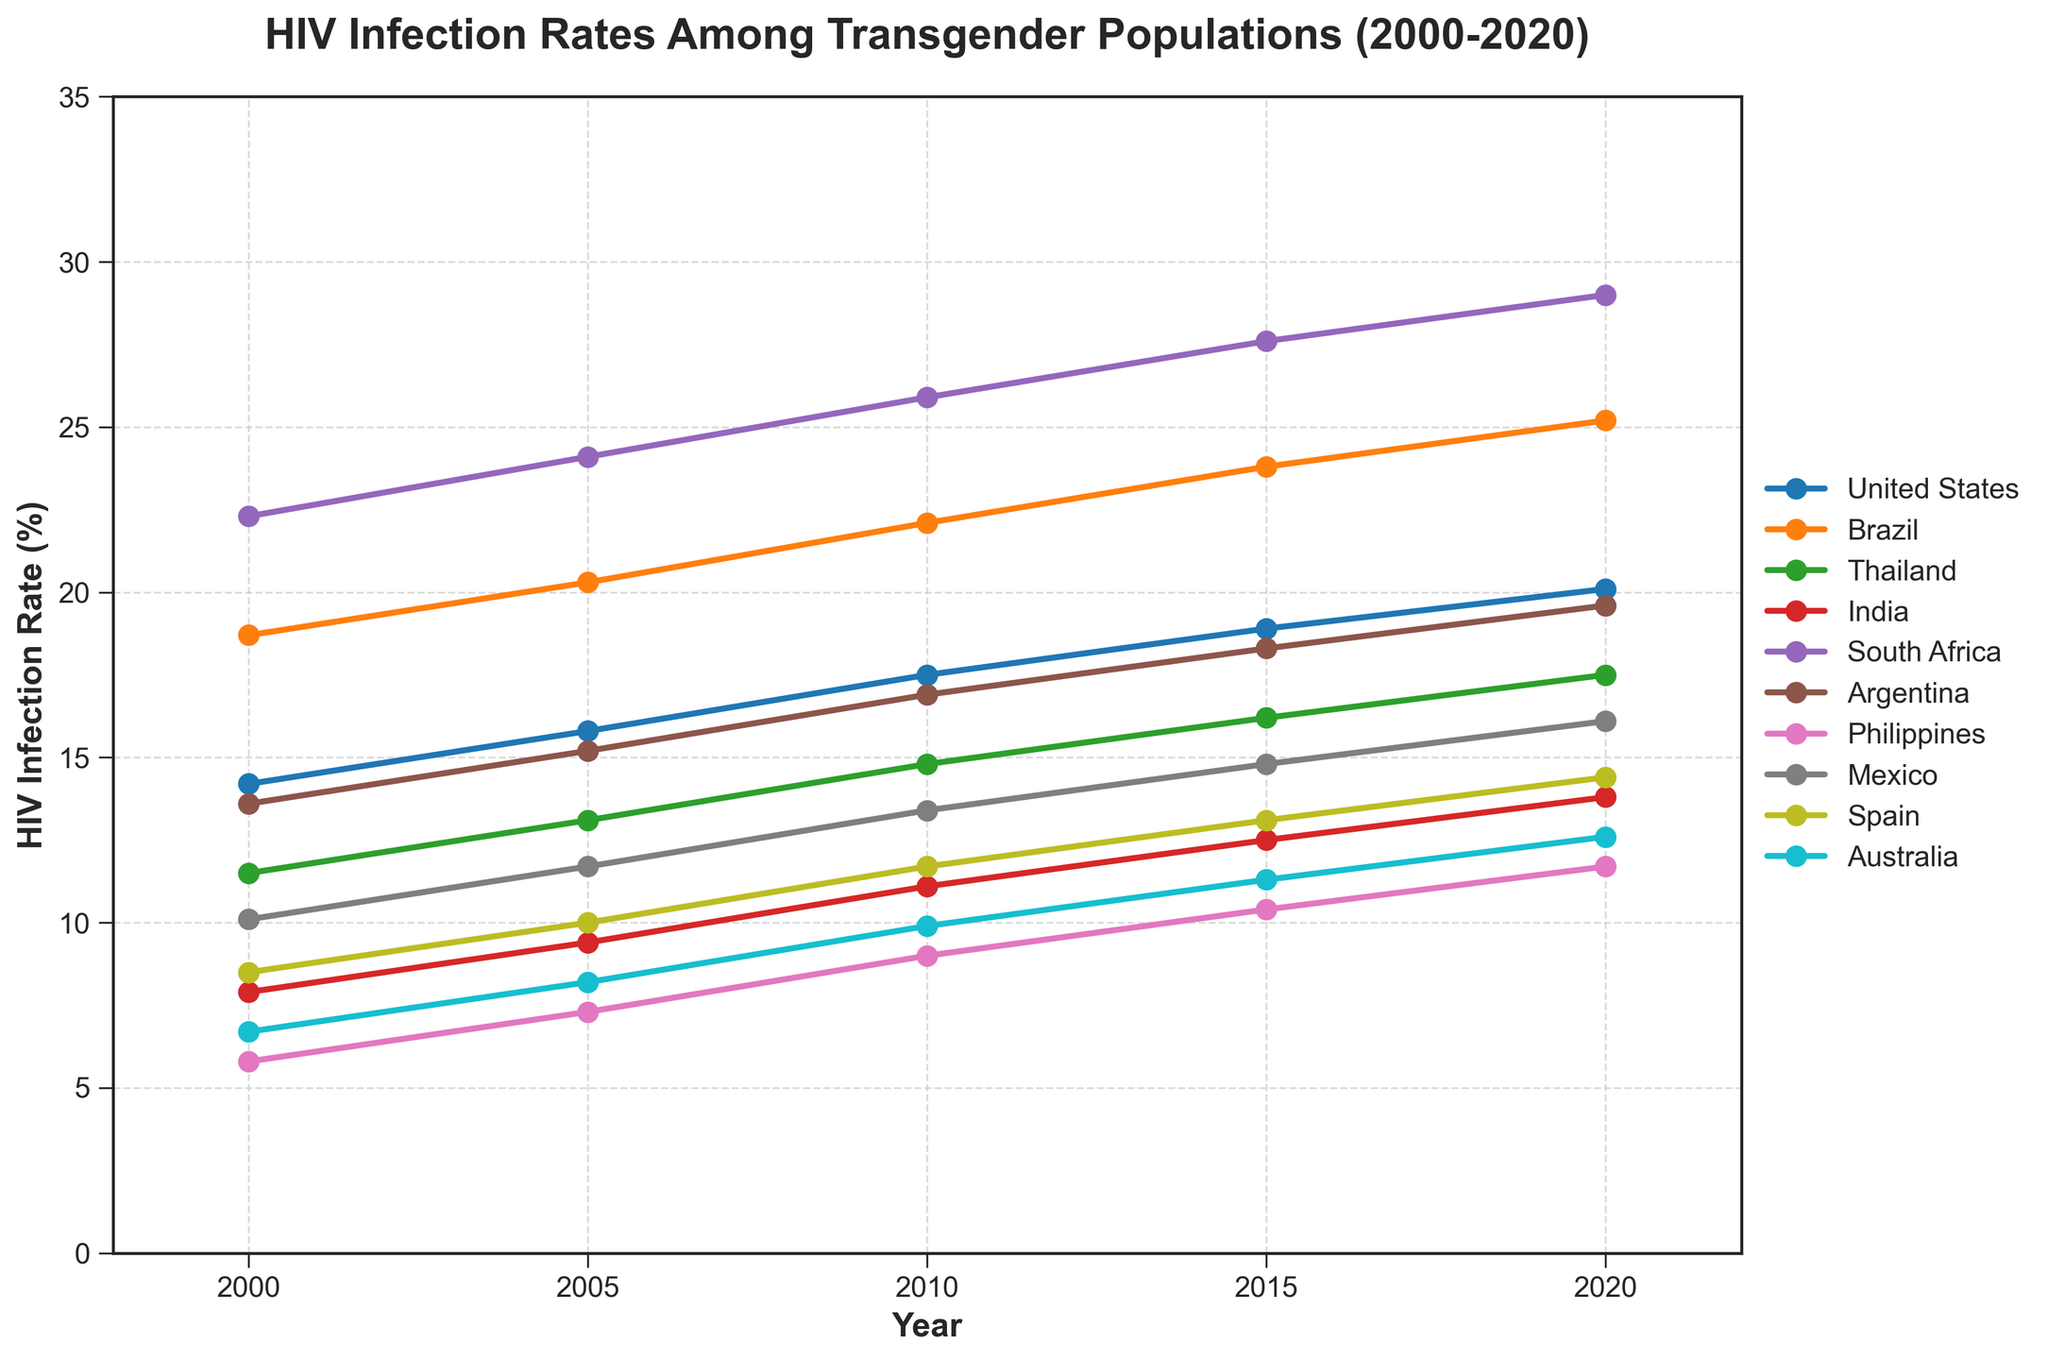What country had the highest HIV infection rate in 2020? Check the rightmost value (2020) of the highest line. South Africa had the highest line at this point.
Answer: South Africa What was the difference in HIV infection rates between Brazil and Thailand in 2010? Identify the data points for Brazil and Thailand in 2010, which are 22.1% and 14.8%, respectively. Subtract Thailand's rate from Brazil's rate: 22.1 - 14.8 = 7.3.
Answer: 7.3 Which country showed the most significant increase in HIV infection rates from 2000 to 2020? Calculate the difference in rates from 2020 and 2000 for each country, and compare these differences. South Africa had an increase from 22.3% to 29.0%, which is 6.7, the highest in absolute terms.
Answer: South Africa How did the HIV infection rates in Argentina and Mexico compare in 2015? Locate the respective 2015 data points: Argentina at 18.3% and Mexico at 14.8%. Compare these values.
Answer: Argentina had higher rates Which country had a lower HIV infection rate in 2005: Spain or Australia? Look at the 2005 data points: Spain had 10.0% and Australia had 8.2%.
Answer: Australia What is the average HIV infection rate in the Philippines over the five recorded years? Add the rates for the Philippines for all five years: 5.8, 7.3, 9.0, 10.4, and 11.7. Sum = 44.2. Average = 44.2 / 5 = 8.84.
Answer: 8.84 In which year did India reach a 10% HIV infection rate, and what was the rate in the next recorded year? Locate the closest higher year above 10%, which is 2010 with 11.1%, followed by 2015 where it is 12.5%.
Answer: 2010; 12.5 Between 2000 and 2010, which country had a more significant increase in HIV infection rates: United States or Brazil? Calculate the rate increase for each: USA (17.5 - 14.2 = 3.3), and Brazil (22.1 - 18.7 = 3.4). Compare these increases.
Answer: Brazil Which country has the steepest line from 2005 to 2010, indicating the fastest increase in this period? Visually inspect the steepness of the upward trends between these years, noting the sharpest increase occurs for the country with the steepest line. Brazil has one of the sharpest inclines.
Answer: Brazil What is the difference in HIV infection rates between Argentina and Spain in 2020? Identify the 2020 data points for Argentina (19.6) and Spain (14.4). Subtract Spain's rate from Argentina's rate: 19.6 - 14.4 = 5.2.
Answer: 5.2 